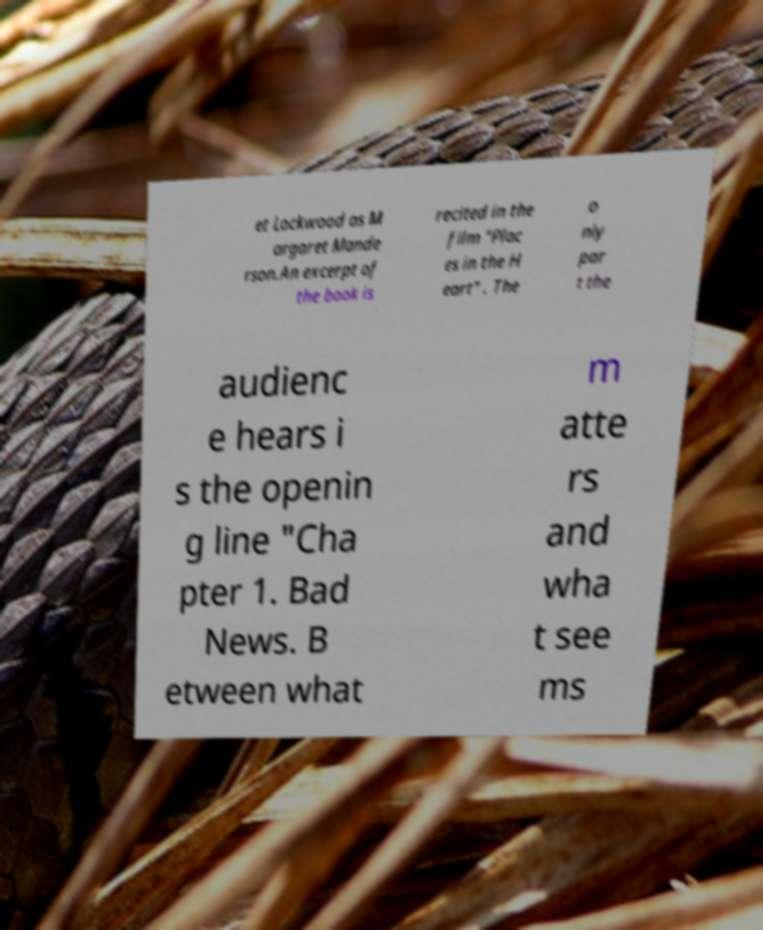Could you extract and type out the text from this image? et Lockwood as M argaret Mande rson.An excerpt of the book is recited in the film "Plac es in the H eart" . The o nly par t the audienc e hears i s the openin g line "Cha pter 1. Bad News. B etween what m atte rs and wha t see ms 